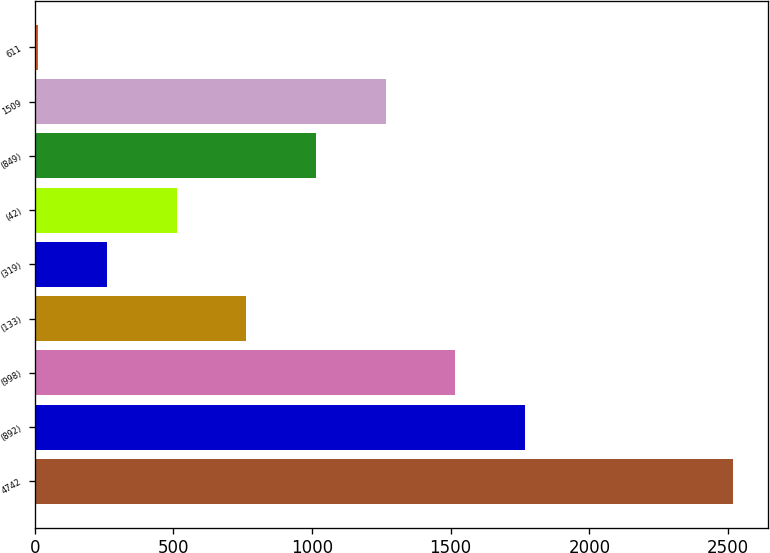Convert chart. <chart><loc_0><loc_0><loc_500><loc_500><bar_chart><fcel>4742<fcel>(892)<fcel>(998)<fcel>(133)<fcel>(319)<fcel>(42)<fcel>(849)<fcel>1509<fcel>611<nl><fcel>2520<fcel>1767.16<fcel>1516.21<fcel>763.36<fcel>261.46<fcel>512.41<fcel>1014.31<fcel>1265.26<fcel>10.51<nl></chart> 